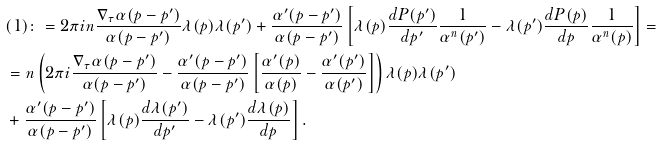Convert formula to latex. <formula><loc_0><loc_0><loc_500><loc_500>& ( 1 ) \colon = 2 \pi i n \frac { \nabla _ { \tau } \alpha ( p - p ^ { \prime } ) } { \alpha ( p - p ^ { \prime } ) } \lambda ( p ) \lambda ( p ^ { \prime } ) + \frac { \alpha ^ { \prime } ( p - p ^ { \prime } ) } { \alpha ( p - p ^ { \prime } ) } \left [ \lambda ( p ) \frac { d P ( p ^ { \prime } ) } { d p ^ { \prime } } \frac { 1 } { \alpha ^ { n } ( p ^ { \prime } ) } - \lambda ( p ^ { \prime } ) \frac { d P ( p ) } { d p } \frac { 1 } { \alpha ^ { n } ( p ) } \right ] = \\ & = n \left ( 2 \pi i \frac { \nabla _ { \tau } \alpha ( p - p ^ { \prime } ) } { \alpha ( p - p ^ { \prime } ) } - \frac { \alpha ^ { \prime } ( p - p ^ { \prime } ) } { \alpha ( p - p ^ { \prime } ) } \left [ \frac { \alpha ^ { \prime } ( p ) } { \alpha ( p ) } - \frac { \alpha ^ { \prime } ( p ^ { \prime } ) } { \alpha ( p ^ { \prime } ) } \right ] \right ) \lambda ( p ) \lambda ( p ^ { \prime } ) \\ & + \frac { \alpha ^ { \prime } ( p - p ^ { \prime } ) } { \alpha ( p - p ^ { \prime } ) } \left [ \lambda ( p ) \frac { d \lambda ( p ^ { \prime } ) } { d p ^ { \prime } } - \lambda ( p ^ { \prime } ) \frac { d \lambda ( p ) } { d p } \right ] .</formula> 